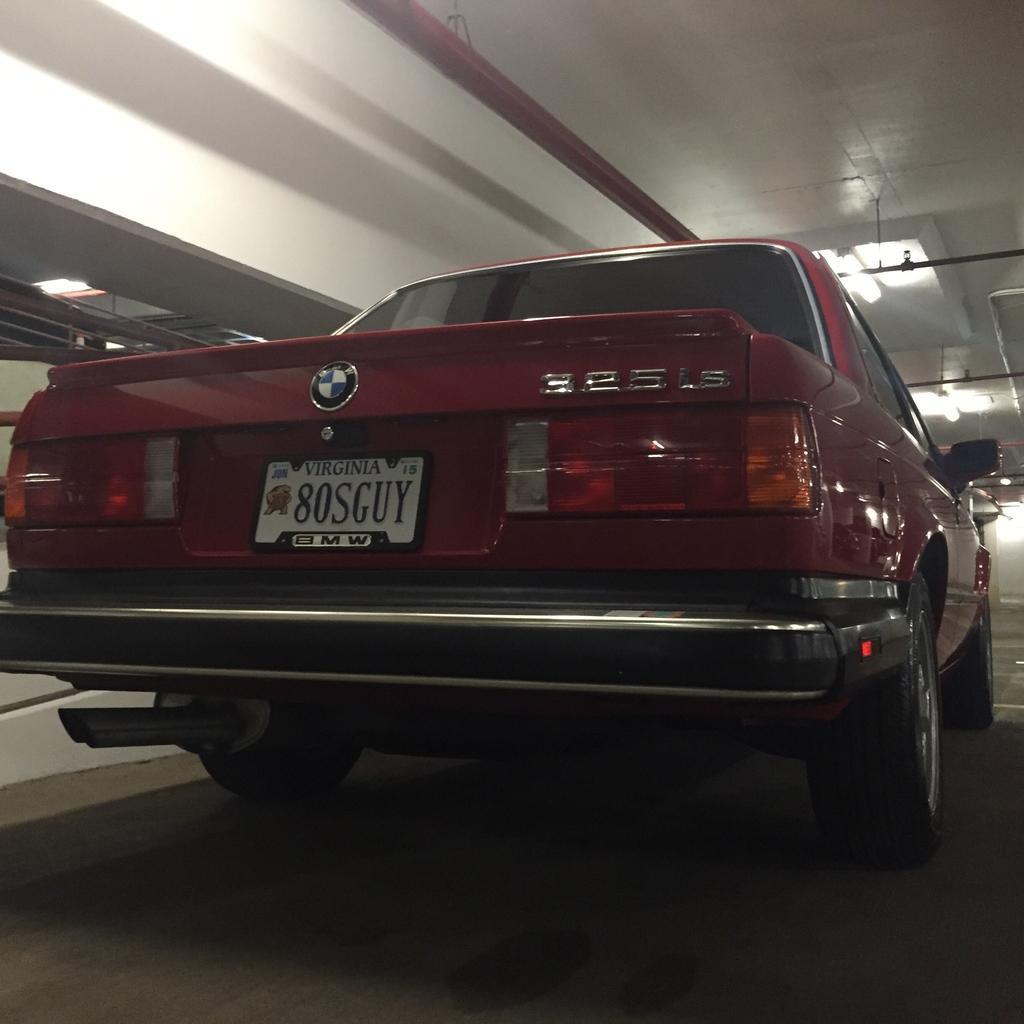Describe this image in one or two sentences. The picture is taken in a room. In the foreground of the picture there is a maroon car. At the top there are lights and pipes. The ceiling is painted white. 